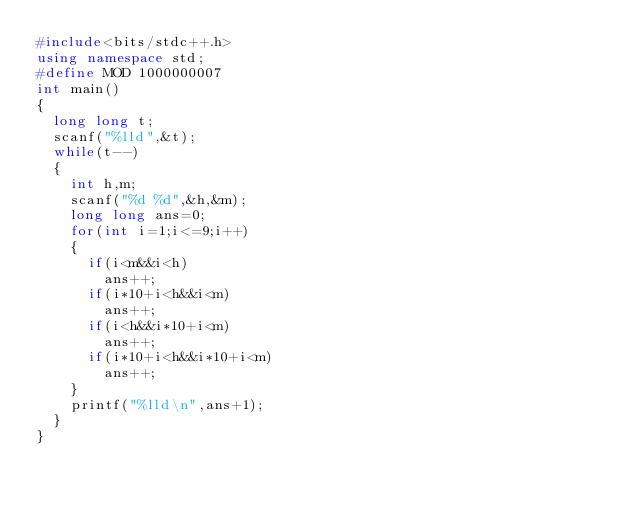Convert code to text. <code><loc_0><loc_0><loc_500><loc_500><_C++_>#include<bits/stdc++.h>
using namespace std;
#define MOD 1000000007
int main()
{
	long long t;
	scanf("%lld",&t);
	while(t--)
	{
		int h,m;
		scanf("%d %d",&h,&m);
		long long ans=0;
		for(int i=1;i<=9;i++)
		{
			if(i<m&&i<h)
				ans++;
			if(i*10+i<h&&i<m)
				ans++;
			if(i<h&&i*10+i<m)
				ans++;
			if(i*10+i<h&&i*10+i<m)
				ans++;
		}
		printf("%lld\n",ans+1);
	}
}
</code> 